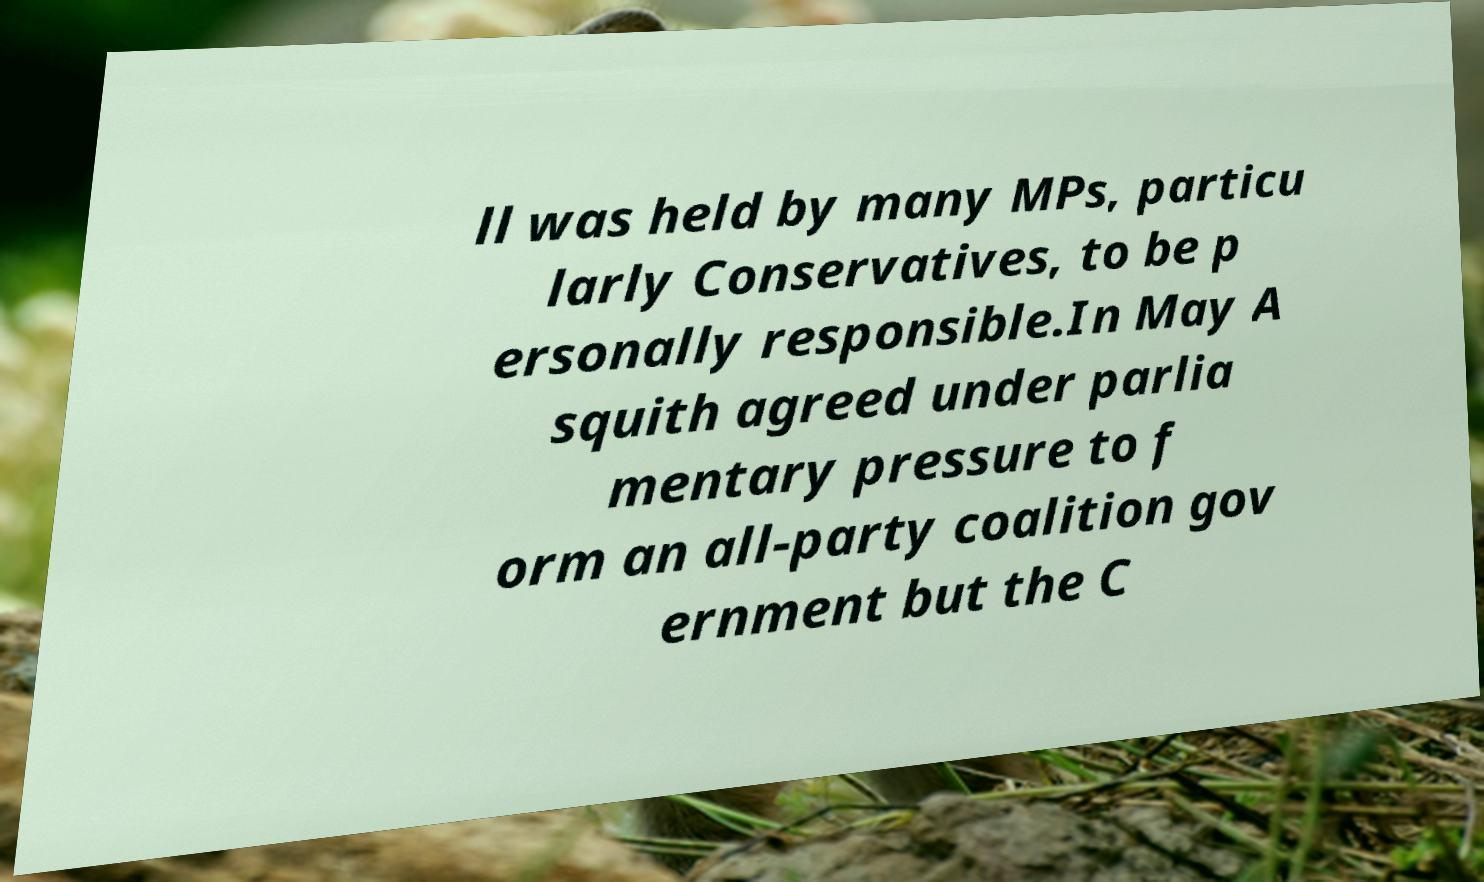Could you extract and type out the text from this image? ll was held by many MPs, particu larly Conservatives, to be p ersonally responsible.In May A squith agreed under parlia mentary pressure to f orm an all-party coalition gov ernment but the C 